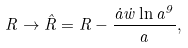<formula> <loc_0><loc_0><loc_500><loc_500>R \to { \hat { R } } = R - \frac { { \dot { a } } { \dot { w } } \ln a ^ { 9 } } { a } ,</formula> 